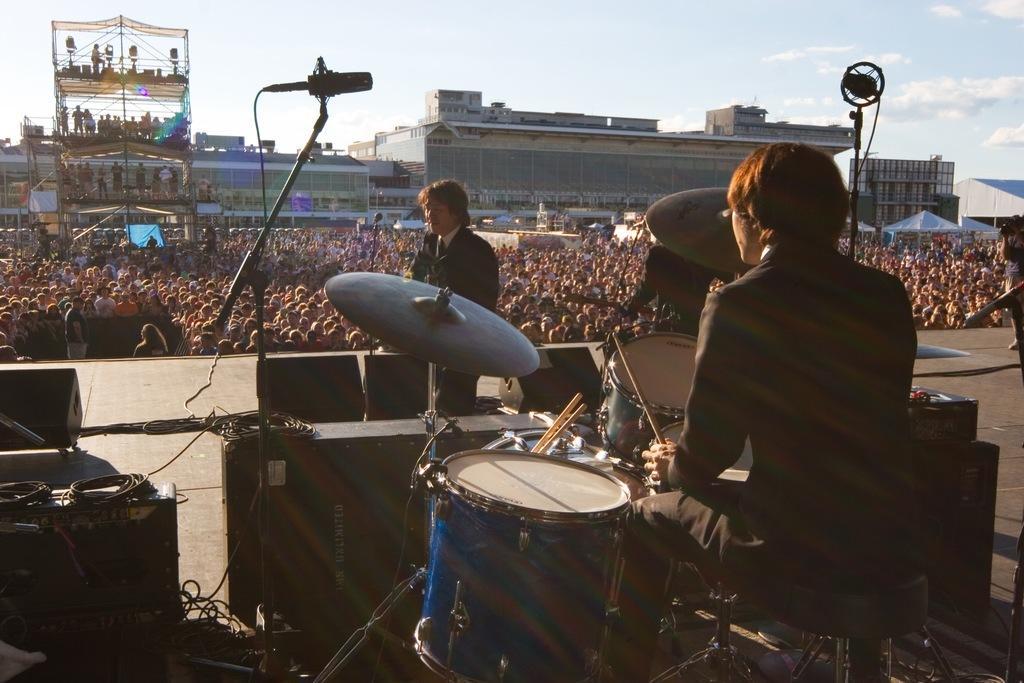Could you give a brief overview of what you see in this image? a person is playing drums. in front of him there is another person standing. in the front there are many people watching them. behind him there are buildings. 